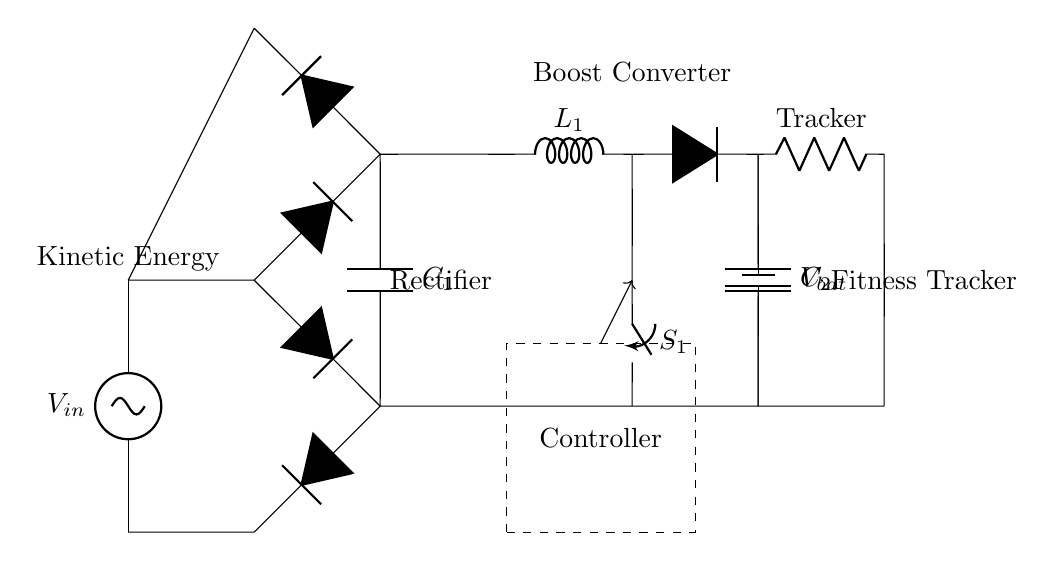What is the energy source of this circuit? The energy source is shown as \( V_{in} \) in the circuit diagram, which is a kinetic energy source.
Answer: Kinetic Energy What type of converter is present in the circuit? The diagram includes a boost converter, indicated by the inductor and other components connected to it, which step up the voltage.
Answer: Boost Converter How many capacitors are in this circuit? There are two capacitors identified as \( C_1 \) and \( C_2 \) in the circuit, both of which are used for filtering.
Answer: Two What is the function of the rectifier in this circuit? The rectifier converts alternating current from the input source \( V_{in} \) to direct current, allowing smooth power delivery to the subsequent components.
Answer: Convert AC to DC What is the load in this circuit? The load is labeled as "Tracker," which likely refers to the fitness tracker that consumes the power generated from the circuit.
Answer: Tracker How does the smoothing capacitor function in this circuit? The smoothing capacitor \( C_1 \) reduces voltage fluctuations after rectification, ensuring a more stable output voltage to the boost converter and load.
Answer: Reduces voltage fluctuations What does the switch \( S_1 \) control in this circuit? The switch \( S_1 \) provides the ability to control the flow of current from the boost converter to the load, allowing for energy management.
Answer: Controls current flow 